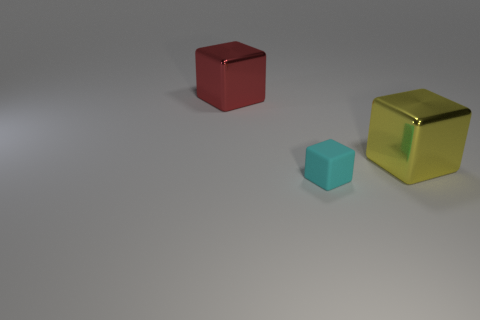Subtract all big blocks. How many blocks are left? 1 Add 1 red metallic cubes. How many objects exist? 4 Subtract all yellow blocks. How many blocks are left? 2 Subtract 2 cubes. How many cubes are left? 1 Subtract all blue spheres. Subtract all big red cubes. How many objects are left? 2 Add 3 big red cubes. How many big red cubes are left? 4 Add 2 large cyan metal cylinders. How many large cyan metal cylinders exist? 2 Subtract 0 blue spheres. How many objects are left? 3 Subtract all yellow blocks. Subtract all red spheres. How many blocks are left? 2 